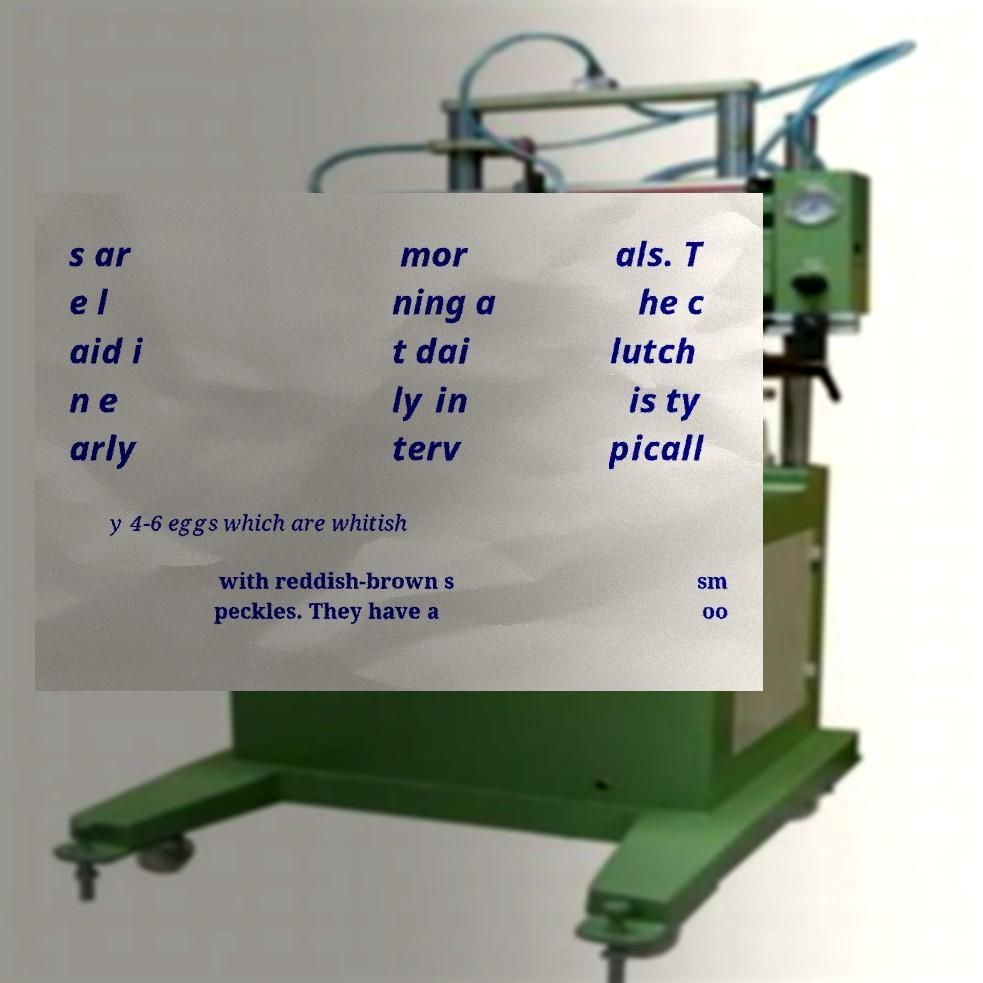Could you extract and type out the text from this image? s ar e l aid i n e arly mor ning a t dai ly in terv als. T he c lutch is ty picall y 4-6 eggs which are whitish with reddish-brown s peckles. They have a sm oo 